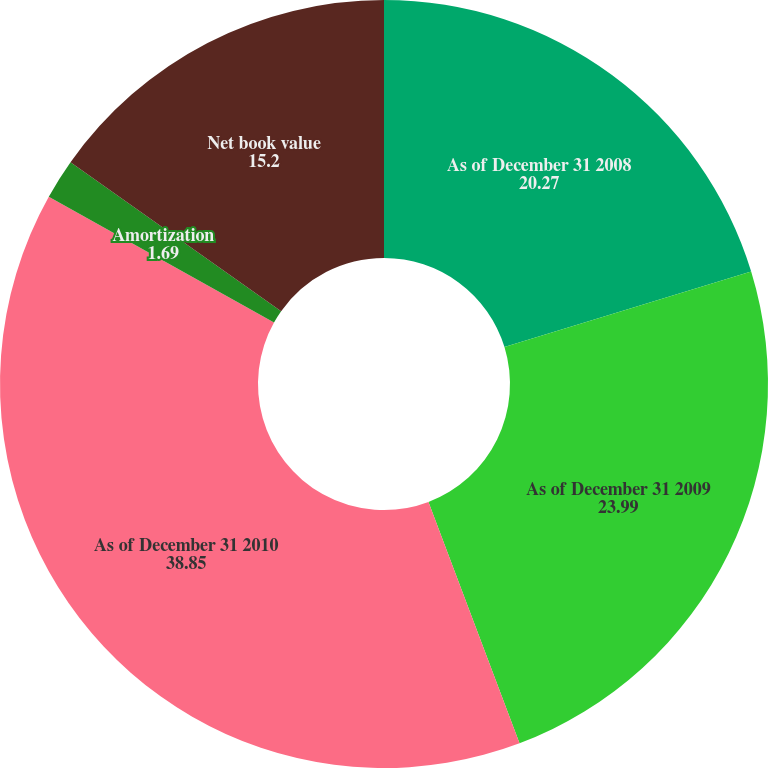Convert chart to OTSL. <chart><loc_0><loc_0><loc_500><loc_500><pie_chart><fcel>As of December 31 2008<fcel>As of December 31 2009<fcel>As of December 31 2010<fcel>Amortization<fcel>Net book value<nl><fcel>20.27%<fcel>23.99%<fcel>38.85%<fcel>1.69%<fcel>15.2%<nl></chart> 